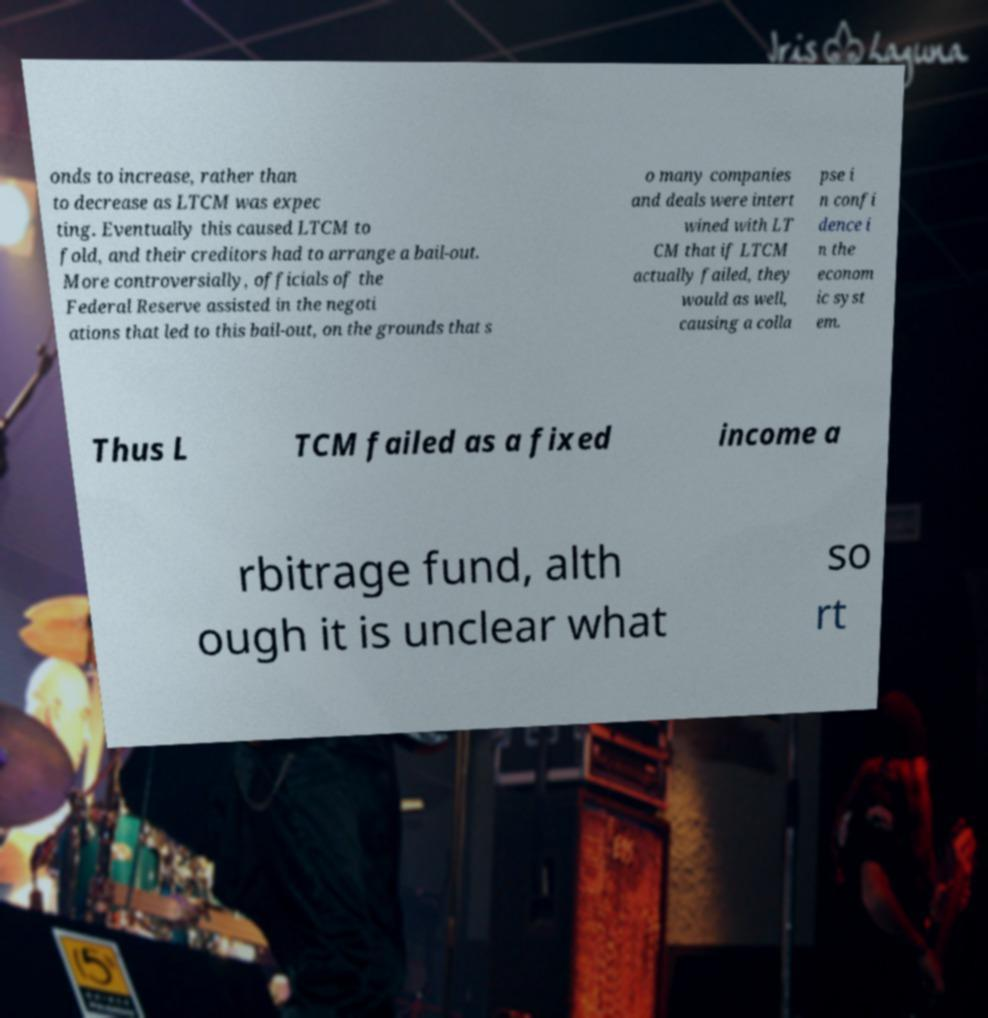There's text embedded in this image that I need extracted. Can you transcribe it verbatim? onds to increase, rather than to decrease as LTCM was expec ting. Eventually this caused LTCM to fold, and their creditors had to arrange a bail-out. More controversially, officials of the Federal Reserve assisted in the negoti ations that led to this bail-out, on the grounds that s o many companies and deals were intert wined with LT CM that if LTCM actually failed, they would as well, causing a colla pse i n confi dence i n the econom ic syst em. Thus L TCM failed as a fixed income a rbitrage fund, alth ough it is unclear what so rt 